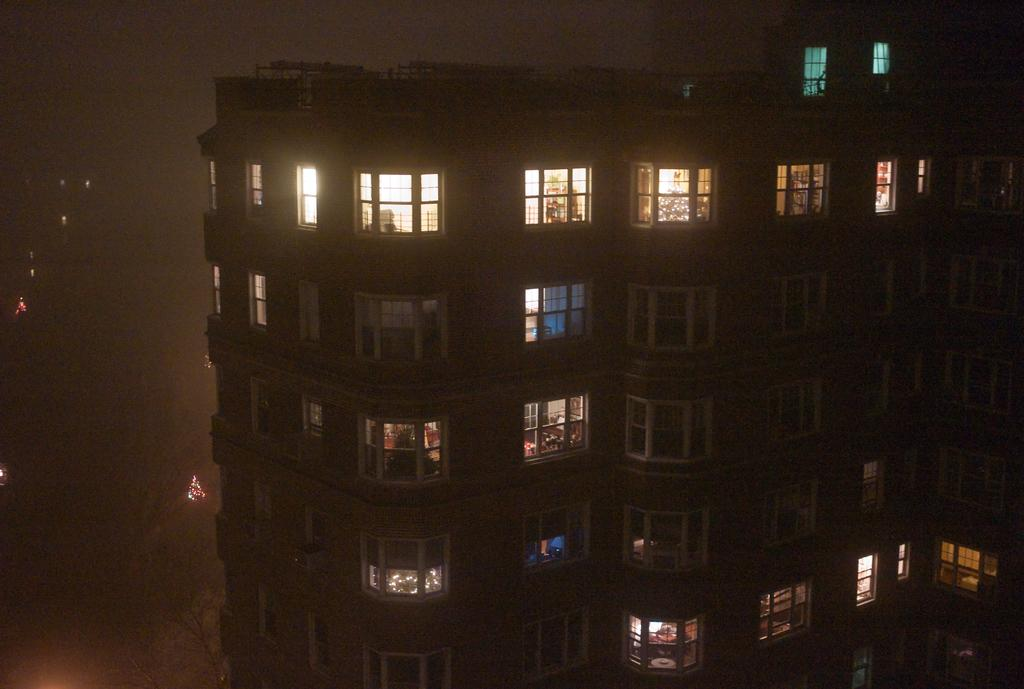What type of structure is visible in the image? There is a building in the image. What features can be observed on the building? The building has windows and lights. How would you describe the background of the image? The background of the image is blurred. What type of vegetation is present at the bottom of the image? There are trees at the bottom of the image. What type of jelly can be seen on the windows of the building in the image? There is no jelly present on the windows of the building in the image. What design is featured on the trees at the bottom of the image? The trees at the bottom of the image do not have any specific design; they are natural vegetation. 